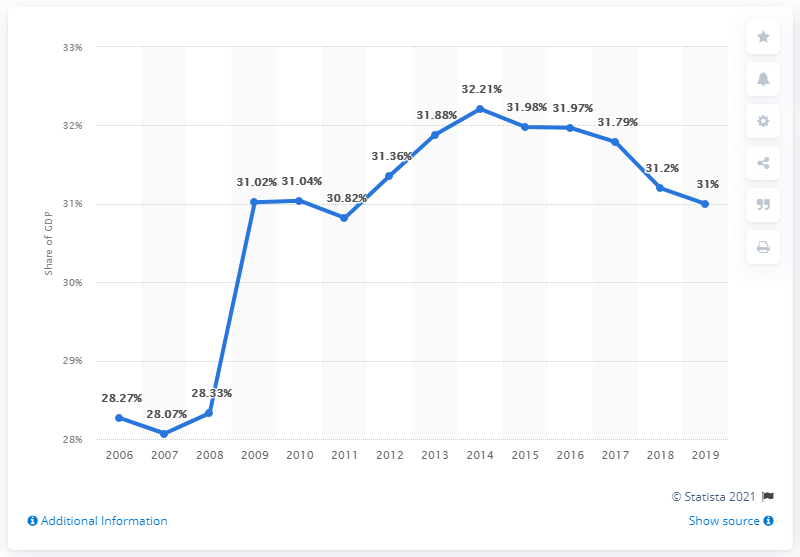Identify some key points in this picture. In 2019, social benefits made up approximately 20% of the French GDP. According to the data provided, the highest share of GDP was 32.21% in the year 2014. In the year 2019, the percentage was 31. 